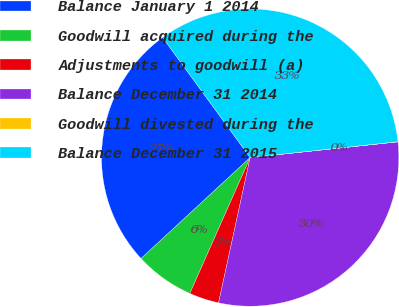<chart> <loc_0><loc_0><loc_500><loc_500><pie_chart><fcel>Balance January 1 2014<fcel>Goodwill acquired during the<fcel>Adjustments to goodwill (a)<fcel>Balance December 31 2014<fcel>Goodwill divested during the<fcel>Balance December 31 2015<nl><fcel>26.86%<fcel>6.47%<fcel>3.24%<fcel>30.09%<fcel>0.02%<fcel>33.32%<nl></chart> 